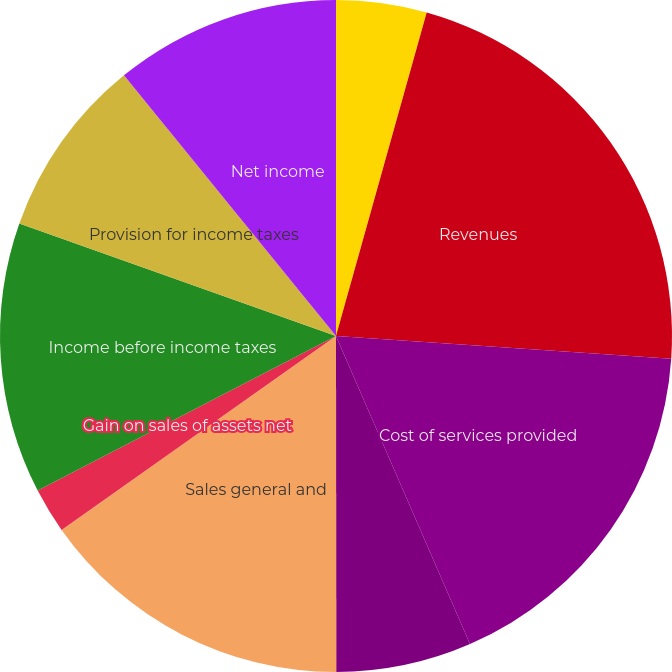Convert chart. <chart><loc_0><loc_0><loc_500><loc_500><pie_chart><fcel>Years ended December 31<fcel>Revenues<fcel>Cost of services provided<fcel>Depreciation and amortization<fcel>Sales general and<fcel>Gain on sales of assets net<fcel>Interest income<fcel>Income before income taxes<fcel>Provision for income taxes<fcel>Net income<nl><fcel>4.35%<fcel>21.73%<fcel>17.39%<fcel>6.52%<fcel>15.22%<fcel>2.18%<fcel>0.0%<fcel>13.04%<fcel>8.7%<fcel>10.87%<nl></chart> 